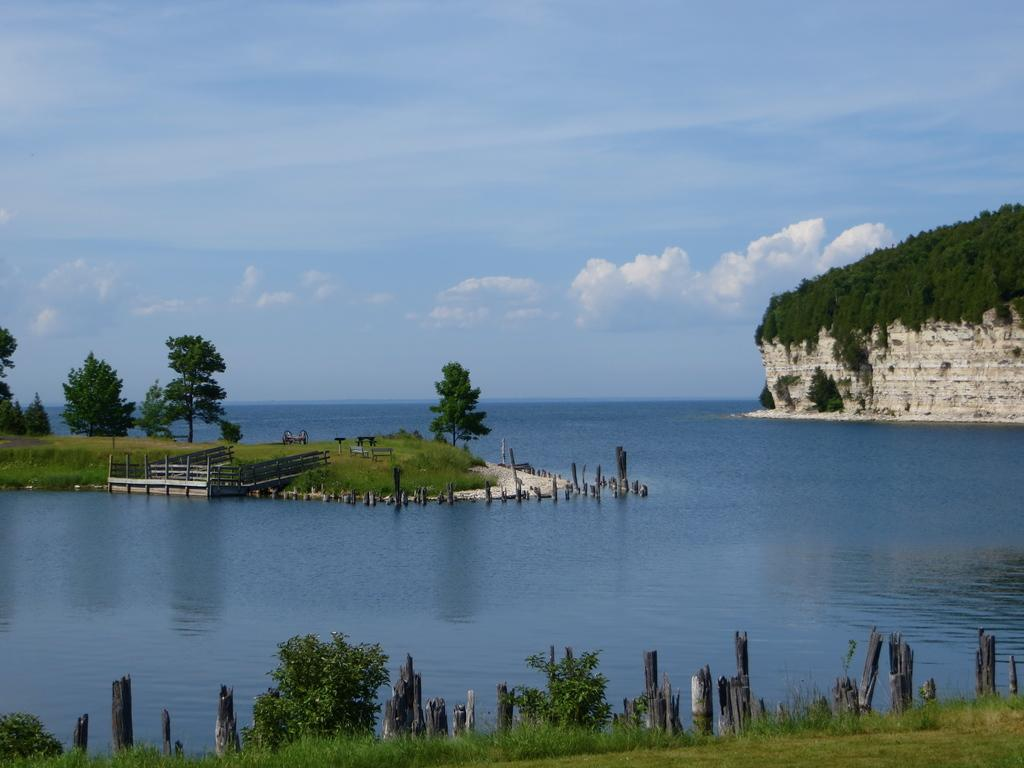What is visible in the image? Water and trees are visible in the image. What can be seen in the background of the image? There are clouds in the background of the image. What type of zinc is being mined in the image? There is no zinc mining activity present in the image; it features water, trees, and clouds. 